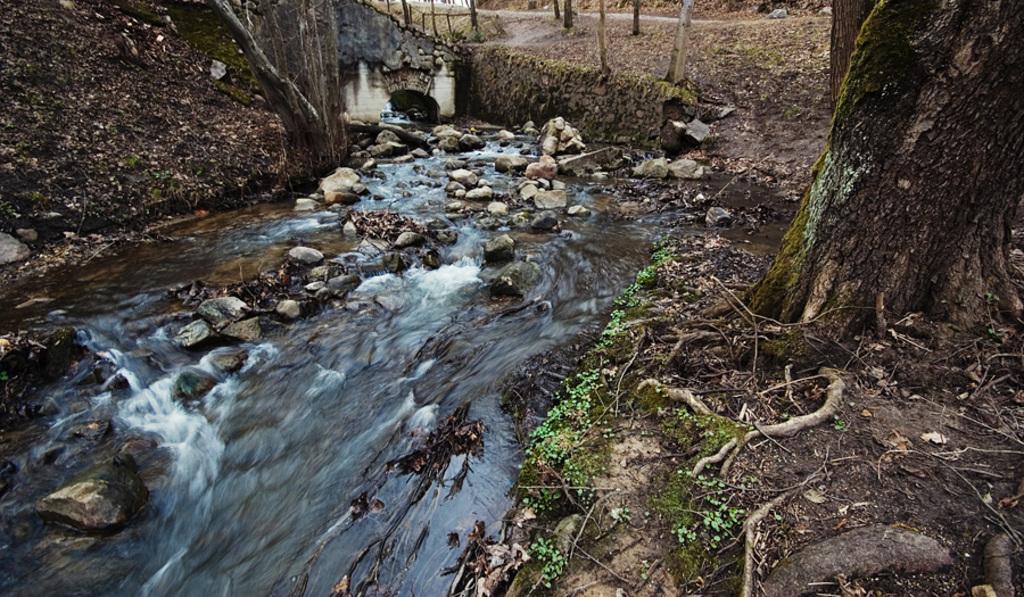In one or two sentences, can you explain what this image depicts? In this image we can see many trunks of the trees. There is a water flow in the image. There are many stones and plants in the image. There is a road in the image. 